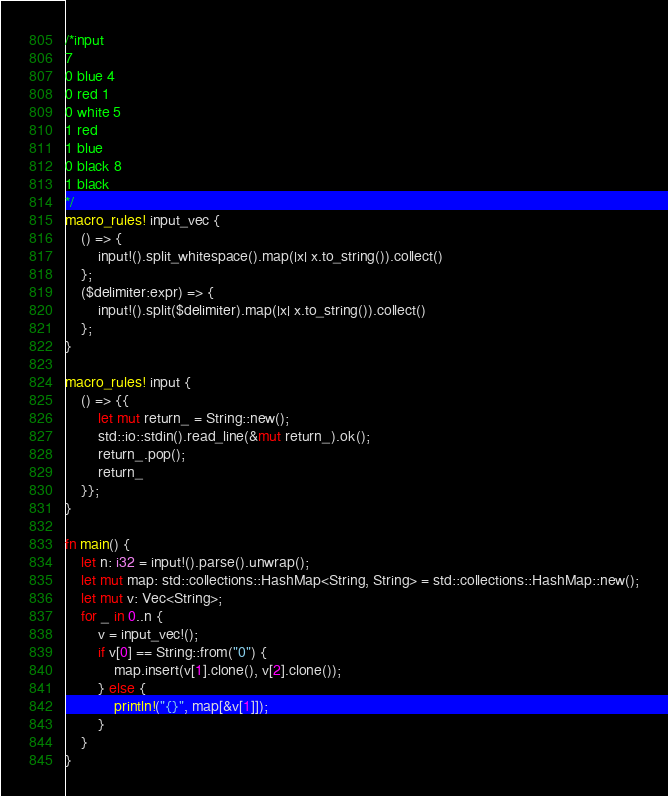Convert code to text. <code><loc_0><loc_0><loc_500><loc_500><_Rust_>/*input
7
0 blue 4
0 red 1
0 white 5
1 red
1 blue
0 black 8
1 black
*/
macro_rules! input_vec {
    () => {
        input!().split_whitespace().map(|x| x.to_string()).collect()
    };
    ($delimiter:expr) => {
        input!().split($delimiter).map(|x| x.to_string()).collect()
    };
}

macro_rules! input {
    () => {{
        let mut return_ = String::new();
        std::io::stdin().read_line(&mut return_).ok();
        return_.pop();
        return_
    }};
}

fn main() {
    let n: i32 = input!().parse().unwrap();
    let mut map: std::collections::HashMap<String, String> = std::collections::HashMap::new();
    let mut v: Vec<String>;
    for _ in 0..n {
        v = input_vec!();
        if v[0] == String::from("0") {
            map.insert(v[1].clone(), v[2].clone());
        } else {
            println!("{}", map[&v[1]]);
        }
    }
}

</code> 